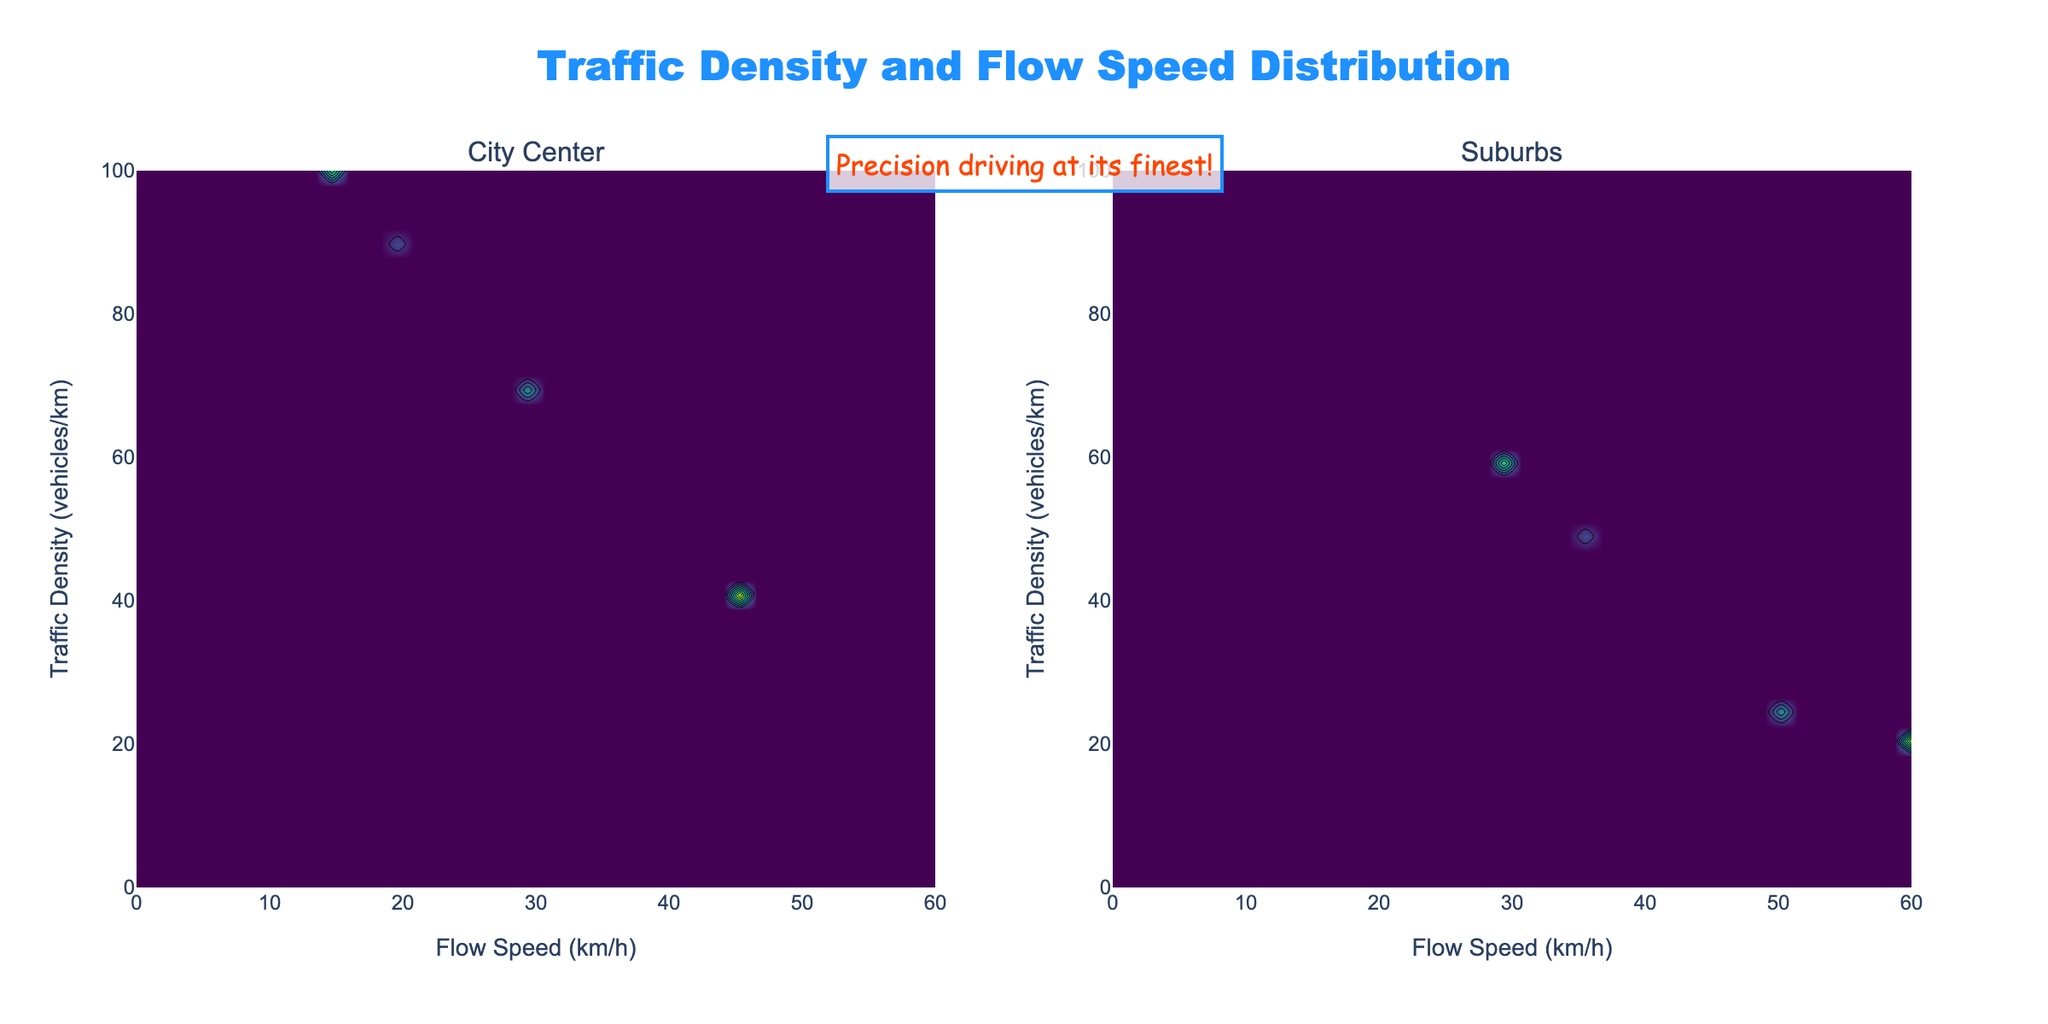What is the title of the figure? The title is prominently displayed at the top of the figure.
Answer: Traffic Density and Flow Speed Distribution What do the color changes in the contour plots represent? The changes in colors represent different times of day, with annotations showing specific time values.
Answer: Different times of day At which time is the traffic density highest in the city center? The dark contour regions show higher traffic densities, and the annotation helps identify the time. The highest density is 100 vehicles/km, occurring at 17:00.
Answer: 17:00 At 12:00, what is the general trend of traffic density between city center and suburbs? Comparing the contour levels at 12:00 for both subplots, city center has higher traffic density.
Answer: Higher in city center What is the flow speed at 08:00 in the suburbs? By looking at the contours for 08:00 in the suburbs plot, the flow speed is around 35 km/h.
Answer: Around 35 km/h During which time of day does the suburbs have the lowest traffic density? The contour levels in the suburbs plot show the lowest traffic density at 22:00.
Answer: 22:00 How does the traffic density and flow speed at 06:00 compare between the city center and suburbs? At 06:00, the city center has a traffic density of 35 vehicles/km at 40 km/h, while suburbs have 15 vehicles/km at 55 km/h.
Answer: City center: 35 vehicles/km at 40 km/h, Suburbs: 15 vehicles/km at 55 km/h Which subplot has a higher traffic density at 22:00? By comparing the contour levels, the city center shows a higher traffic density of 40 vehicles/km compared to 20 vehicles/km in suburbs.
Answer: City center What is the flow speed at the highest traffic density in the city center? The highest traffic density in the city center is at 100 vehicles/km, and the corresponding flow speed is about 15 km/h.
Answer: About 15 km/h 